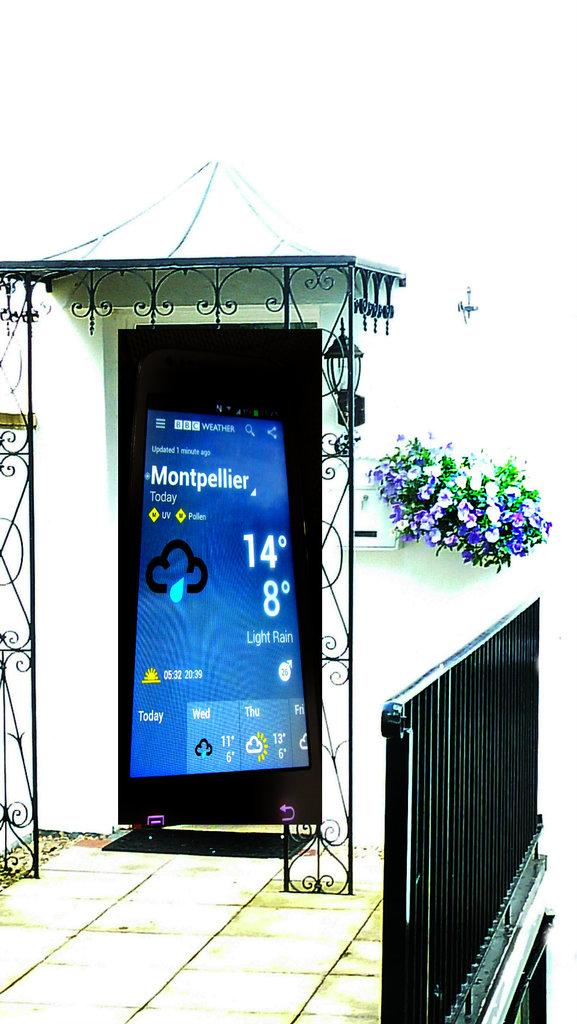<image>
Describe the image concisely. The large screen of an oversize cell phone contains the temperature is 14 degrees and 8 degrees on it. 